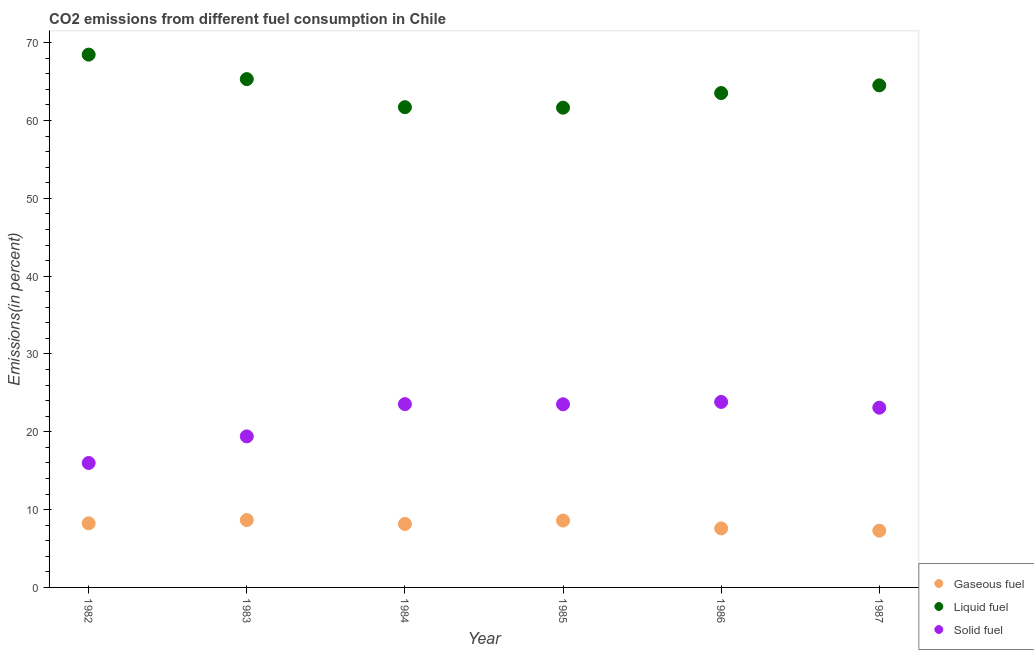How many different coloured dotlines are there?
Your answer should be very brief. 3. Is the number of dotlines equal to the number of legend labels?
Make the answer very short. Yes. What is the percentage of liquid fuel emission in 1985?
Give a very brief answer. 61.65. Across all years, what is the maximum percentage of liquid fuel emission?
Your answer should be compact. 68.46. Across all years, what is the minimum percentage of liquid fuel emission?
Provide a short and direct response. 61.65. In which year was the percentage of liquid fuel emission maximum?
Ensure brevity in your answer.  1982. In which year was the percentage of solid fuel emission minimum?
Your answer should be compact. 1982. What is the total percentage of liquid fuel emission in the graph?
Provide a short and direct response. 385.18. What is the difference between the percentage of solid fuel emission in 1985 and that in 1986?
Offer a terse response. -0.3. What is the difference between the percentage of liquid fuel emission in 1985 and the percentage of solid fuel emission in 1984?
Ensure brevity in your answer.  38.09. What is the average percentage of gaseous fuel emission per year?
Your response must be concise. 8.09. In the year 1986, what is the difference between the percentage of solid fuel emission and percentage of liquid fuel emission?
Your answer should be compact. -39.69. In how many years, is the percentage of liquid fuel emission greater than 28 %?
Give a very brief answer. 6. What is the ratio of the percentage of gaseous fuel emission in 1984 to that in 1985?
Give a very brief answer. 0.95. Is the percentage of gaseous fuel emission in 1985 less than that in 1987?
Keep it short and to the point. No. Is the difference between the percentage of gaseous fuel emission in 1986 and 1987 greater than the difference between the percentage of liquid fuel emission in 1986 and 1987?
Ensure brevity in your answer.  Yes. What is the difference between the highest and the second highest percentage of solid fuel emission?
Provide a short and direct response. 0.28. What is the difference between the highest and the lowest percentage of gaseous fuel emission?
Provide a short and direct response. 1.36. In how many years, is the percentage of solid fuel emission greater than the average percentage of solid fuel emission taken over all years?
Provide a short and direct response. 4. Is the percentage of gaseous fuel emission strictly greater than the percentage of liquid fuel emission over the years?
Make the answer very short. No. Is the percentage of liquid fuel emission strictly less than the percentage of gaseous fuel emission over the years?
Offer a terse response. No. How many dotlines are there?
Provide a short and direct response. 3. Are the values on the major ticks of Y-axis written in scientific E-notation?
Your response must be concise. No. Does the graph contain any zero values?
Your answer should be compact. No. What is the title of the graph?
Provide a short and direct response. CO2 emissions from different fuel consumption in Chile. What is the label or title of the X-axis?
Offer a terse response. Year. What is the label or title of the Y-axis?
Make the answer very short. Emissions(in percent). What is the Emissions(in percent) of Gaseous fuel in 1982?
Offer a terse response. 8.24. What is the Emissions(in percent) of Liquid fuel in 1982?
Give a very brief answer. 68.46. What is the Emissions(in percent) of Solid fuel in 1982?
Provide a succinct answer. 15.99. What is the Emissions(in percent) of Gaseous fuel in 1983?
Make the answer very short. 8.66. What is the Emissions(in percent) in Liquid fuel in 1983?
Give a very brief answer. 65.32. What is the Emissions(in percent) in Solid fuel in 1983?
Make the answer very short. 19.41. What is the Emissions(in percent) of Gaseous fuel in 1984?
Offer a very short reply. 8.16. What is the Emissions(in percent) in Liquid fuel in 1984?
Your answer should be very brief. 61.71. What is the Emissions(in percent) of Solid fuel in 1984?
Provide a short and direct response. 23.55. What is the Emissions(in percent) of Gaseous fuel in 1985?
Keep it short and to the point. 8.59. What is the Emissions(in percent) of Liquid fuel in 1985?
Make the answer very short. 61.65. What is the Emissions(in percent) of Solid fuel in 1985?
Give a very brief answer. 23.53. What is the Emissions(in percent) of Gaseous fuel in 1986?
Offer a terse response. 7.58. What is the Emissions(in percent) in Liquid fuel in 1986?
Offer a very short reply. 63.52. What is the Emissions(in percent) in Solid fuel in 1986?
Your response must be concise. 23.83. What is the Emissions(in percent) of Gaseous fuel in 1987?
Your answer should be compact. 7.29. What is the Emissions(in percent) of Liquid fuel in 1987?
Keep it short and to the point. 64.52. What is the Emissions(in percent) of Solid fuel in 1987?
Your answer should be compact. 23.1. Across all years, what is the maximum Emissions(in percent) in Gaseous fuel?
Offer a terse response. 8.66. Across all years, what is the maximum Emissions(in percent) in Liquid fuel?
Make the answer very short. 68.46. Across all years, what is the maximum Emissions(in percent) in Solid fuel?
Offer a very short reply. 23.83. Across all years, what is the minimum Emissions(in percent) in Gaseous fuel?
Your answer should be very brief. 7.29. Across all years, what is the minimum Emissions(in percent) in Liquid fuel?
Provide a short and direct response. 61.65. Across all years, what is the minimum Emissions(in percent) of Solid fuel?
Make the answer very short. 15.99. What is the total Emissions(in percent) of Gaseous fuel in the graph?
Offer a very short reply. 48.52. What is the total Emissions(in percent) of Liquid fuel in the graph?
Provide a succinct answer. 385.18. What is the total Emissions(in percent) in Solid fuel in the graph?
Your response must be concise. 129.42. What is the difference between the Emissions(in percent) in Gaseous fuel in 1982 and that in 1983?
Provide a short and direct response. -0.42. What is the difference between the Emissions(in percent) of Liquid fuel in 1982 and that in 1983?
Provide a short and direct response. 3.15. What is the difference between the Emissions(in percent) in Solid fuel in 1982 and that in 1983?
Give a very brief answer. -3.42. What is the difference between the Emissions(in percent) of Gaseous fuel in 1982 and that in 1984?
Make the answer very short. 0.08. What is the difference between the Emissions(in percent) in Liquid fuel in 1982 and that in 1984?
Give a very brief answer. 6.75. What is the difference between the Emissions(in percent) in Solid fuel in 1982 and that in 1984?
Keep it short and to the point. -7.56. What is the difference between the Emissions(in percent) in Gaseous fuel in 1982 and that in 1985?
Offer a very short reply. -0.36. What is the difference between the Emissions(in percent) in Liquid fuel in 1982 and that in 1985?
Provide a short and direct response. 6.82. What is the difference between the Emissions(in percent) in Solid fuel in 1982 and that in 1985?
Ensure brevity in your answer.  -7.54. What is the difference between the Emissions(in percent) in Gaseous fuel in 1982 and that in 1986?
Your answer should be compact. 0.65. What is the difference between the Emissions(in percent) of Liquid fuel in 1982 and that in 1986?
Provide a succinct answer. 4.94. What is the difference between the Emissions(in percent) in Solid fuel in 1982 and that in 1986?
Offer a terse response. -7.84. What is the difference between the Emissions(in percent) in Gaseous fuel in 1982 and that in 1987?
Make the answer very short. 0.94. What is the difference between the Emissions(in percent) in Liquid fuel in 1982 and that in 1987?
Keep it short and to the point. 3.95. What is the difference between the Emissions(in percent) in Solid fuel in 1982 and that in 1987?
Keep it short and to the point. -7.1. What is the difference between the Emissions(in percent) in Gaseous fuel in 1983 and that in 1984?
Your response must be concise. 0.5. What is the difference between the Emissions(in percent) of Liquid fuel in 1983 and that in 1984?
Your answer should be compact. 3.61. What is the difference between the Emissions(in percent) in Solid fuel in 1983 and that in 1984?
Give a very brief answer. -4.15. What is the difference between the Emissions(in percent) in Gaseous fuel in 1983 and that in 1985?
Give a very brief answer. 0.06. What is the difference between the Emissions(in percent) of Liquid fuel in 1983 and that in 1985?
Provide a succinct answer. 3.67. What is the difference between the Emissions(in percent) in Solid fuel in 1983 and that in 1985?
Your answer should be very brief. -4.12. What is the difference between the Emissions(in percent) in Gaseous fuel in 1983 and that in 1986?
Make the answer very short. 1.08. What is the difference between the Emissions(in percent) of Liquid fuel in 1983 and that in 1986?
Give a very brief answer. 1.79. What is the difference between the Emissions(in percent) in Solid fuel in 1983 and that in 1986?
Offer a terse response. -4.43. What is the difference between the Emissions(in percent) in Gaseous fuel in 1983 and that in 1987?
Your answer should be very brief. 1.36. What is the difference between the Emissions(in percent) of Liquid fuel in 1983 and that in 1987?
Your response must be concise. 0.8. What is the difference between the Emissions(in percent) of Solid fuel in 1983 and that in 1987?
Give a very brief answer. -3.69. What is the difference between the Emissions(in percent) of Gaseous fuel in 1984 and that in 1985?
Provide a succinct answer. -0.43. What is the difference between the Emissions(in percent) of Liquid fuel in 1984 and that in 1985?
Provide a short and direct response. 0.06. What is the difference between the Emissions(in percent) in Solid fuel in 1984 and that in 1985?
Make the answer very short. 0.02. What is the difference between the Emissions(in percent) of Gaseous fuel in 1984 and that in 1986?
Keep it short and to the point. 0.58. What is the difference between the Emissions(in percent) of Liquid fuel in 1984 and that in 1986?
Your answer should be compact. -1.81. What is the difference between the Emissions(in percent) of Solid fuel in 1984 and that in 1986?
Your answer should be compact. -0.28. What is the difference between the Emissions(in percent) in Gaseous fuel in 1984 and that in 1987?
Offer a very short reply. 0.87. What is the difference between the Emissions(in percent) of Liquid fuel in 1984 and that in 1987?
Give a very brief answer. -2.8. What is the difference between the Emissions(in percent) in Solid fuel in 1984 and that in 1987?
Offer a very short reply. 0.46. What is the difference between the Emissions(in percent) of Gaseous fuel in 1985 and that in 1986?
Offer a very short reply. 1.01. What is the difference between the Emissions(in percent) in Liquid fuel in 1985 and that in 1986?
Give a very brief answer. -1.88. What is the difference between the Emissions(in percent) in Solid fuel in 1985 and that in 1986?
Give a very brief answer. -0.3. What is the difference between the Emissions(in percent) in Gaseous fuel in 1985 and that in 1987?
Your response must be concise. 1.3. What is the difference between the Emissions(in percent) in Liquid fuel in 1985 and that in 1987?
Your answer should be compact. -2.87. What is the difference between the Emissions(in percent) of Solid fuel in 1985 and that in 1987?
Your response must be concise. 0.44. What is the difference between the Emissions(in percent) of Gaseous fuel in 1986 and that in 1987?
Make the answer very short. 0.29. What is the difference between the Emissions(in percent) in Liquid fuel in 1986 and that in 1987?
Offer a very short reply. -0.99. What is the difference between the Emissions(in percent) of Solid fuel in 1986 and that in 1987?
Keep it short and to the point. 0.74. What is the difference between the Emissions(in percent) of Gaseous fuel in 1982 and the Emissions(in percent) of Liquid fuel in 1983?
Your answer should be compact. -57.08. What is the difference between the Emissions(in percent) of Gaseous fuel in 1982 and the Emissions(in percent) of Solid fuel in 1983?
Provide a short and direct response. -11.17. What is the difference between the Emissions(in percent) of Liquid fuel in 1982 and the Emissions(in percent) of Solid fuel in 1983?
Keep it short and to the point. 49.05. What is the difference between the Emissions(in percent) of Gaseous fuel in 1982 and the Emissions(in percent) of Liquid fuel in 1984?
Make the answer very short. -53.48. What is the difference between the Emissions(in percent) of Gaseous fuel in 1982 and the Emissions(in percent) of Solid fuel in 1984?
Offer a very short reply. -15.32. What is the difference between the Emissions(in percent) in Liquid fuel in 1982 and the Emissions(in percent) in Solid fuel in 1984?
Your response must be concise. 44.91. What is the difference between the Emissions(in percent) in Gaseous fuel in 1982 and the Emissions(in percent) in Liquid fuel in 1985?
Your answer should be very brief. -53.41. What is the difference between the Emissions(in percent) of Gaseous fuel in 1982 and the Emissions(in percent) of Solid fuel in 1985?
Your answer should be compact. -15.3. What is the difference between the Emissions(in percent) in Liquid fuel in 1982 and the Emissions(in percent) in Solid fuel in 1985?
Offer a terse response. 44.93. What is the difference between the Emissions(in percent) of Gaseous fuel in 1982 and the Emissions(in percent) of Liquid fuel in 1986?
Make the answer very short. -55.29. What is the difference between the Emissions(in percent) of Gaseous fuel in 1982 and the Emissions(in percent) of Solid fuel in 1986?
Offer a terse response. -15.6. What is the difference between the Emissions(in percent) of Liquid fuel in 1982 and the Emissions(in percent) of Solid fuel in 1986?
Make the answer very short. 44.63. What is the difference between the Emissions(in percent) in Gaseous fuel in 1982 and the Emissions(in percent) in Liquid fuel in 1987?
Provide a succinct answer. -56.28. What is the difference between the Emissions(in percent) of Gaseous fuel in 1982 and the Emissions(in percent) of Solid fuel in 1987?
Offer a terse response. -14.86. What is the difference between the Emissions(in percent) of Liquid fuel in 1982 and the Emissions(in percent) of Solid fuel in 1987?
Provide a succinct answer. 45.37. What is the difference between the Emissions(in percent) in Gaseous fuel in 1983 and the Emissions(in percent) in Liquid fuel in 1984?
Your answer should be very brief. -53.05. What is the difference between the Emissions(in percent) in Gaseous fuel in 1983 and the Emissions(in percent) in Solid fuel in 1984?
Give a very brief answer. -14.9. What is the difference between the Emissions(in percent) of Liquid fuel in 1983 and the Emissions(in percent) of Solid fuel in 1984?
Your answer should be very brief. 41.76. What is the difference between the Emissions(in percent) in Gaseous fuel in 1983 and the Emissions(in percent) in Liquid fuel in 1985?
Offer a terse response. -52.99. What is the difference between the Emissions(in percent) of Gaseous fuel in 1983 and the Emissions(in percent) of Solid fuel in 1985?
Offer a terse response. -14.88. What is the difference between the Emissions(in percent) in Liquid fuel in 1983 and the Emissions(in percent) in Solid fuel in 1985?
Your answer should be very brief. 41.78. What is the difference between the Emissions(in percent) in Gaseous fuel in 1983 and the Emissions(in percent) in Liquid fuel in 1986?
Provide a succinct answer. -54.87. What is the difference between the Emissions(in percent) in Gaseous fuel in 1983 and the Emissions(in percent) in Solid fuel in 1986?
Provide a succinct answer. -15.18. What is the difference between the Emissions(in percent) in Liquid fuel in 1983 and the Emissions(in percent) in Solid fuel in 1986?
Your answer should be very brief. 41.48. What is the difference between the Emissions(in percent) of Gaseous fuel in 1983 and the Emissions(in percent) of Liquid fuel in 1987?
Offer a terse response. -55.86. What is the difference between the Emissions(in percent) of Gaseous fuel in 1983 and the Emissions(in percent) of Solid fuel in 1987?
Keep it short and to the point. -14.44. What is the difference between the Emissions(in percent) of Liquid fuel in 1983 and the Emissions(in percent) of Solid fuel in 1987?
Your answer should be compact. 42.22. What is the difference between the Emissions(in percent) in Gaseous fuel in 1984 and the Emissions(in percent) in Liquid fuel in 1985?
Make the answer very short. -53.49. What is the difference between the Emissions(in percent) in Gaseous fuel in 1984 and the Emissions(in percent) in Solid fuel in 1985?
Make the answer very short. -15.37. What is the difference between the Emissions(in percent) in Liquid fuel in 1984 and the Emissions(in percent) in Solid fuel in 1985?
Give a very brief answer. 38.18. What is the difference between the Emissions(in percent) of Gaseous fuel in 1984 and the Emissions(in percent) of Liquid fuel in 1986?
Your answer should be compact. -55.36. What is the difference between the Emissions(in percent) of Gaseous fuel in 1984 and the Emissions(in percent) of Solid fuel in 1986?
Provide a succinct answer. -15.67. What is the difference between the Emissions(in percent) in Liquid fuel in 1984 and the Emissions(in percent) in Solid fuel in 1986?
Offer a very short reply. 37.88. What is the difference between the Emissions(in percent) of Gaseous fuel in 1984 and the Emissions(in percent) of Liquid fuel in 1987?
Give a very brief answer. -56.36. What is the difference between the Emissions(in percent) of Gaseous fuel in 1984 and the Emissions(in percent) of Solid fuel in 1987?
Your answer should be compact. -14.94. What is the difference between the Emissions(in percent) of Liquid fuel in 1984 and the Emissions(in percent) of Solid fuel in 1987?
Your answer should be very brief. 38.62. What is the difference between the Emissions(in percent) of Gaseous fuel in 1985 and the Emissions(in percent) of Liquid fuel in 1986?
Offer a terse response. -54.93. What is the difference between the Emissions(in percent) in Gaseous fuel in 1985 and the Emissions(in percent) in Solid fuel in 1986?
Your answer should be compact. -15.24. What is the difference between the Emissions(in percent) of Liquid fuel in 1985 and the Emissions(in percent) of Solid fuel in 1986?
Ensure brevity in your answer.  37.81. What is the difference between the Emissions(in percent) of Gaseous fuel in 1985 and the Emissions(in percent) of Liquid fuel in 1987?
Keep it short and to the point. -55.92. What is the difference between the Emissions(in percent) in Gaseous fuel in 1985 and the Emissions(in percent) in Solid fuel in 1987?
Your response must be concise. -14.5. What is the difference between the Emissions(in percent) of Liquid fuel in 1985 and the Emissions(in percent) of Solid fuel in 1987?
Your answer should be very brief. 38.55. What is the difference between the Emissions(in percent) of Gaseous fuel in 1986 and the Emissions(in percent) of Liquid fuel in 1987?
Make the answer very short. -56.93. What is the difference between the Emissions(in percent) in Gaseous fuel in 1986 and the Emissions(in percent) in Solid fuel in 1987?
Offer a terse response. -15.51. What is the difference between the Emissions(in percent) in Liquid fuel in 1986 and the Emissions(in percent) in Solid fuel in 1987?
Provide a succinct answer. 40.43. What is the average Emissions(in percent) in Gaseous fuel per year?
Offer a very short reply. 8.09. What is the average Emissions(in percent) of Liquid fuel per year?
Provide a short and direct response. 64.2. What is the average Emissions(in percent) in Solid fuel per year?
Keep it short and to the point. 21.57. In the year 1982, what is the difference between the Emissions(in percent) in Gaseous fuel and Emissions(in percent) in Liquid fuel?
Provide a succinct answer. -60.23. In the year 1982, what is the difference between the Emissions(in percent) in Gaseous fuel and Emissions(in percent) in Solid fuel?
Your answer should be very brief. -7.76. In the year 1982, what is the difference between the Emissions(in percent) in Liquid fuel and Emissions(in percent) in Solid fuel?
Keep it short and to the point. 52.47. In the year 1983, what is the difference between the Emissions(in percent) in Gaseous fuel and Emissions(in percent) in Liquid fuel?
Your response must be concise. -56.66. In the year 1983, what is the difference between the Emissions(in percent) in Gaseous fuel and Emissions(in percent) in Solid fuel?
Your answer should be very brief. -10.75. In the year 1983, what is the difference between the Emissions(in percent) in Liquid fuel and Emissions(in percent) in Solid fuel?
Your answer should be compact. 45.91. In the year 1984, what is the difference between the Emissions(in percent) in Gaseous fuel and Emissions(in percent) in Liquid fuel?
Keep it short and to the point. -53.55. In the year 1984, what is the difference between the Emissions(in percent) of Gaseous fuel and Emissions(in percent) of Solid fuel?
Make the answer very short. -15.39. In the year 1984, what is the difference between the Emissions(in percent) in Liquid fuel and Emissions(in percent) in Solid fuel?
Offer a terse response. 38.16. In the year 1985, what is the difference between the Emissions(in percent) of Gaseous fuel and Emissions(in percent) of Liquid fuel?
Provide a short and direct response. -53.05. In the year 1985, what is the difference between the Emissions(in percent) of Gaseous fuel and Emissions(in percent) of Solid fuel?
Provide a succinct answer. -14.94. In the year 1985, what is the difference between the Emissions(in percent) in Liquid fuel and Emissions(in percent) in Solid fuel?
Provide a short and direct response. 38.11. In the year 1986, what is the difference between the Emissions(in percent) in Gaseous fuel and Emissions(in percent) in Liquid fuel?
Your response must be concise. -55.94. In the year 1986, what is the difference between the Emissions(in percent) in Gaseous fuel and Emissions(in percent) in Solid fuel?
Provide a succinct answer. -16.25. In the year 1986, what is the difference between the Emissions(in percent) in Liquid fuel and Emissions(in percent) in Solid fuel?
Your answer should be very brief. 39.69. In the year 1987, what is the difference between the Emissions(in percent) in Gaseous fuel and Emissions(in percent) in Liquid fuel?
Your answer should be compact. -57.22. In the year 1987, what is the difference between the Emissions(in percent) of Gaseous fuel and Emissions(in percent) of Solid fuel?
Your answer should be compact. -15.8. In the year 1987, what is the difference between the Emissions(in percent) of Liquid fuel and Emissions(in percent) of Solid fuel?
Provide a succinct answer. 41.42. What is the ratio of the Emissions(in percent) of Gaseous fuel in 1982 to that in 1983?
Your answer should be very brief. 0.95. What is the ratio of the Emissions(in percent) in Liquid fuel in 1982 to that in 1983?
Make the answer very short. 1.05. What is the ratio of the Emissions(in percent) in Solid fuel in 1982 to that in 1983?
Ensure brevity in your answer.  0.82. What is the ratio of the Emissions(in percent) in Gaseous fuel in 1982 to that in 1984?
Ensure brevity in your answer.  1.01. What is the ratio of the Emissions(in percent) of Liquid fuel in 1982 to that in 1984?
Your response must be concise. 1.11. What is the ratio of the Emissions(in percent) of Solid fuel in 1982 to that in 1984?
Offer a very short reply. 0.68. What is the ratio of the Emissions(in percent) of Gaseous fuel in 1982 to that in 1985?
Make the answer very short. 0.96. What is the ratio of the Emissions(in percent) of Liquid fuel in 1982 to that in 1985?
Your answer should be compact. 1.11. What is the ratio of the Emissions(in percent) in Solid fuel in 1982 to that in 1985?
Your answer should be very brief. 0.68. What is the ratio of the Emissions(in percent) of Gaseous fuel in 1982 to that in 1986?
Give a very brief answer. 1.09. What is the ratio of the Emissions(in percent) of Liquid fuel in 1982 to that in 1986?
Your response must be concise. 1.08. What is the ratio of the Emissions(in percent) in Solid fuel in 1982 to that in 1986?
Offer a terse response. 0.67. What is the ratio of the Emissions(in percent) of Gaseous fuel in 1982 to that in 1987?
Ensure brevity in your answer.  1.13. What is the ratio of the Emissions(in percent) in Liquid fuel in 1982 to that in 1987?
Provide a succinct answer. 1.06. What is the ratio of the Emissions(in percent) in Solid fuel in 1982 to that in 1987?
Ensure brevity in your answer.  0.69. What is the ratio of the Emissions(in percent) in Gaseous fuel in 1983 to that in 1984?
Your answer should be compact. 1.06. What is the ratio of the Emissions(in percent) of Liquid fuel in 1983 to that in 1984?
Ensure brevity in your answer.  1.06. What is the ratio of the Emissions(in percent) of Solid fuel in 1983 to that in 1984?
Keep it short and to the point. 0.82. What is the ratio of the Emissions(in percent) in Gaseous fuel in 1983 to that in 1985?
Provide a short and direct response. 1.01. What is the ratio of the Emissions(in percent) in Liquid fuel in 1983 to that in 1985?
Provide a short and direct response. 1.06. What is the ratio of the Emissions(in percent) in Solid fuel in 1983 to that in 1985?
Provide a succinct answer. 0.82. What is the ratio of the Emissions(in percent) of Gaseous fuel in 1983 to that in 1986?
Offer a very short reply. 1.14. What is the ratio of the Emissions(in percent) of Liquid fuel in 1983 to that in 1986?
Offer a terse response. 1.03. What is the ratio of the Emissions(in percent) of Solid fuel in 1983 to that in 1986?
Your response must be concise. 0.81. What is the ratio of the Emissions(in percent) of Gaseous fuel in 1983 to that in 1987?
Keep it short and to the point. 1.19. What is the ratio of the Emissions(in percent) of Liquid fuel in 1983 to that in 1987?
Your response must be concise. 1.01. What is the ratio of the Emissions(in percent) of Solid fuel in 1983 to that in 1987?
Keep it short and to the point. 0.84. What is the ratio of the Emissions(in percent) in Gaseous fuel in 1984 to that in 1985?
Make the answer very short. 0.95. What is the ratio of the Emissions(in percent) in Liquid fuel in 1984 to that in 1985?
Offer a very short reply. 1. What is the ratio of the Emissions(in percent) in Gaseous fuel in 1984 to that in 1986?
Make the answer very short. 1.08. What is the ratio of the Emissions(in percent) of Liquid fuel in 1984 to that in 1986?
Make the answer very short. 0.97. What is the ratio of the Emissions(in percent) of Solid fuel in 1984 to that in 1986?
Your response must be concise. 0.99. What is the ratio of the Emissions(in percent) of Gaseous fuel in 1984 to that in 1987?
Ensure brevity in your answer.  1.12. What is the ratio of the Emissions(in percent) of Liquid fuel in 1984 to that in 1987?
Your answer should be very brief. 0.96. What is the ratio of the Emissions(in percent) in Solid fuel in 1984 to that in 1987?
Provide a succinct answer. 1.02. What is the ratio of the Emissions(in percent) in Gaseous fuel in 1985 to that in 1986?
Provide a succinct answer. 1.13. What is the ratio of the Emissions(in percent) in Liquid fuel in 1985 to that in 1986?
Your answer should be very brief. 0.97. What is the ratio of the Emissions(in percent) in Solid fuel in 1985 to that in 1986?
Your answer should be very brief. 0.99. What is the ratio of the Emissions(in percent) in Gaseous fuel in 1985 to that in 1987?
Give a very brief answer. 1.18. What is the ratio of the Emissions(in percent) of Liquid fuel in 1985 to that in 1987?
Your answer should be compact. 0.96. What is the ratio of the Emissions(in percent) of Gaseous fuel in 1986 to that in 1987?
Make the answer very short. 1.04. What is the ratio of the Emissions(in percent) of Liquid fuel in 1986 to that in 1987?
Your answer should be compact. 0.98. What is the ratio of the Emissions(in percent) of Solid fuel in 1986 to that in 1987?
Keep it short and to the point. 1.03. What is the difference between the highest and the second highest Emissions(in percent) in Gaseous fuel?
Give a very brief answer. 0.06. What is the difference between the highest and the second highest Emissions(in percent) of Liquid fuel?
Provide a short and direct response. 3.15. What is the difference between the highest and the second highest Emissions(in percent) in Solid fuel?
Offer a very short reply. 0.28. What is the difference between the highest and the lowest Emissions(in percent) in Gaseous fuel?
Provide a short and direct response. 1.36. What is the difference between the highest and the lowest Emissions(in percent) of Liquid fuel?
Provide a succinct answer. 6.82. What is the difference between the highest and the lowest Emissions(in percent) in Solid fuel?
Ensure brevity in your answer.  7.84. 